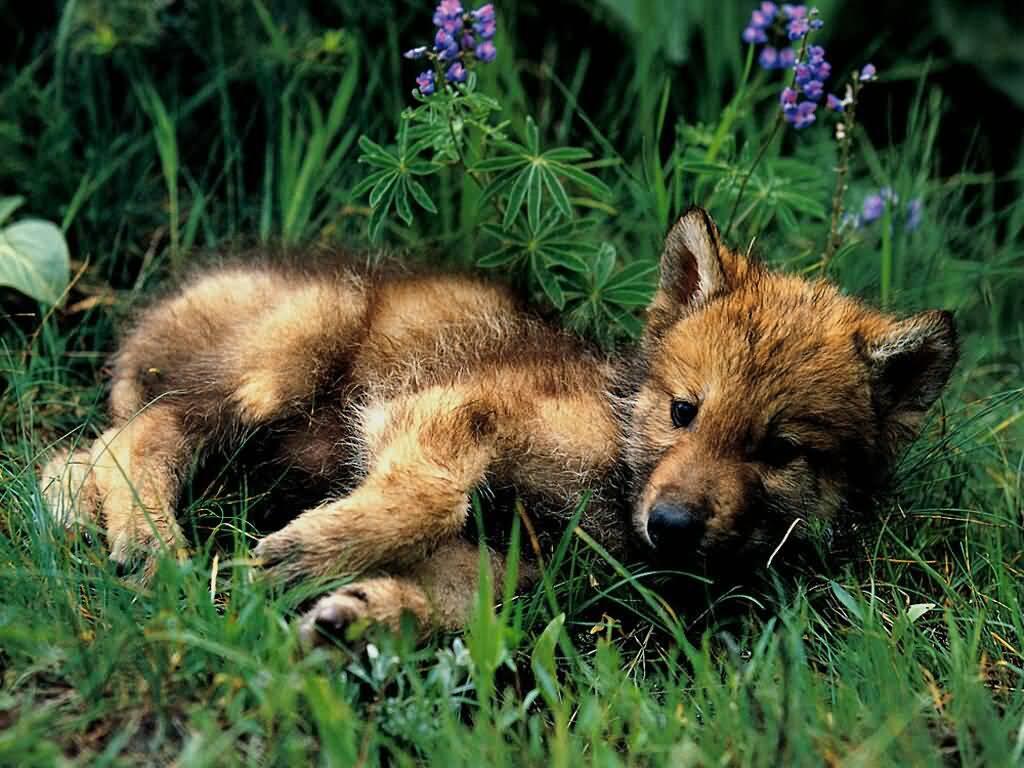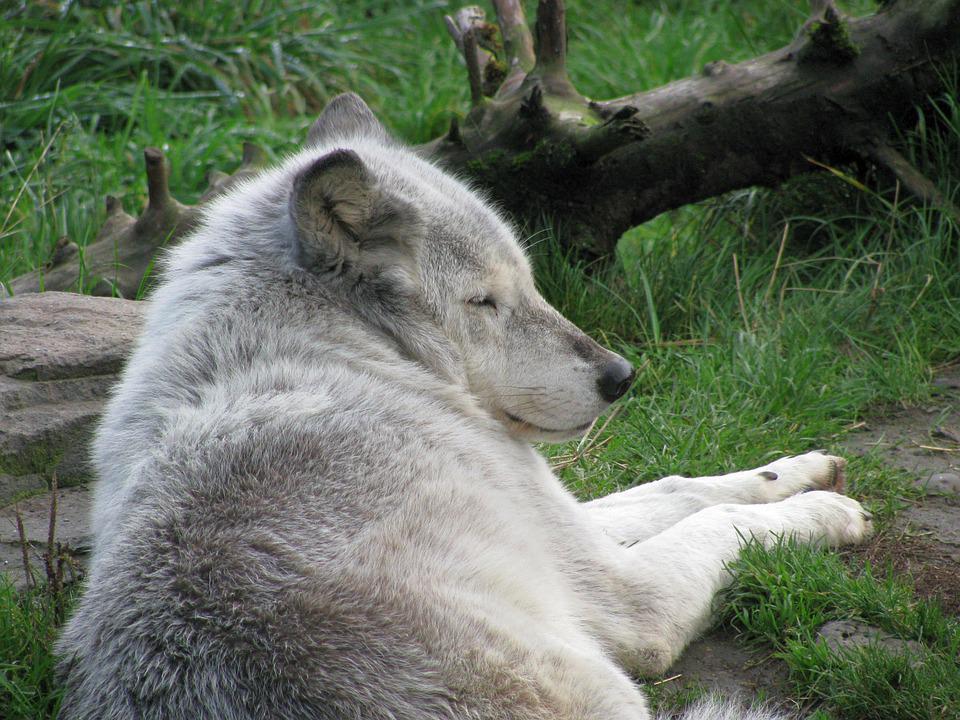The first image is the image on the left, the second image is the image on the right. Assess this claim about the two images: "In the left image, two animals are laying down together.". Correct or not? Answer yes or no. No. The first image is the image on the left, the second image is the image on the right. For the images shown, is this caption "One animal is lying their head across the body of another animal." true? Answer yes or no. No. 